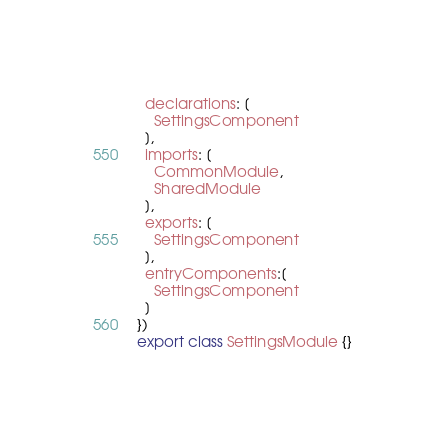<code> <loc_0><loc_0><loc_500><loc_500><_TypeScript_>  declarations: [
    SettingsComponent
  ],
  imports: [
  	CommonModule,
  	SharedModule
  ],
  exports: [
    SettingsComponent
  ],
  entryComponents:[
  	SettingsComponent
  ]
})
export class SettingsModule {}
</code> 